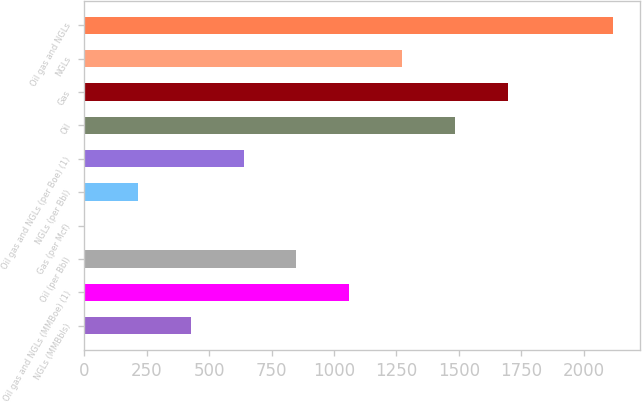Convert chart. <chart><loc_0><loc_0><loc_500><loc_500><bar_chart><fcel>NGLs (MMBbls)<fcel>Oil gas and NGLs (MMBoe) (1)<fcel>Oil (per Bbl)<fcel>Gas (per Mcf)<fcel>NGLs (per Bbl)<fcel>Oil gas and NGLs (per Boe) (1)<fcel>Oil<fcel>Gas<fcel>NGLs<fcel>Oil gas and NGLs<nl><fcel>426.13<fcel>1060.96<fcel>849.35<fcel>2.91<fcel>214.52<fcel>637.74<fcel>1484.18<fcel>1695.79<fcel>1272.57<fcel>2119<nl></chart> 